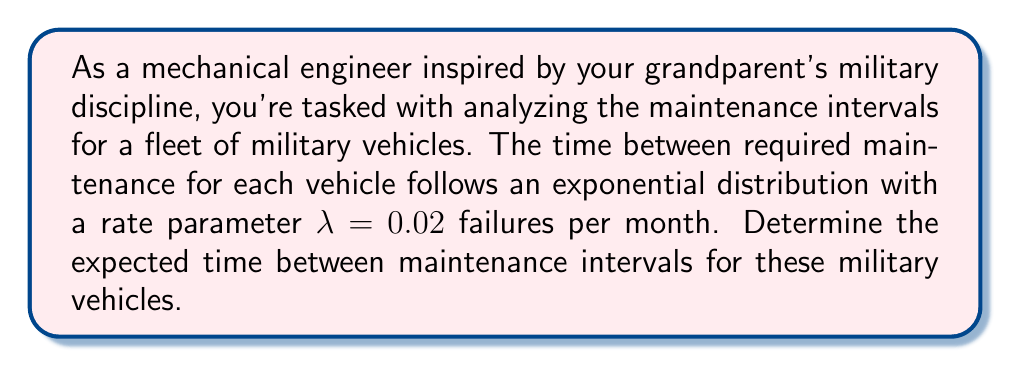Can you solve this math problem? Let's approach this step-by-step:

1) For an exponential distribution, the expected value (mean) is given by:

   $$ E[X] = \frac{1}{\lambda} $$

   where λ is the rate parameter.

2) We're given that λ = 0.02 failures per month.

3) Substituting this into our formula:

   $$ E[X] = \frac{1}{0.02} $$

4) Calculating this:

   $$ E[X] = 50 $$

5) Therefore, the expected time between maintenance intervals is 50 months.

6) To convert this to years for a more practical interpretation:

   $$ 50 \text{ months} \times \frac{1 \text{ year}}{12 \text{ months}} \approx 4.17 \text{ years} $$

This result aligns with the military's need for long-lasting, reliable equipment, reflecting the discipline and efficiency that your grandparent might have valued in their military career.
Answer: 50 months or approximately 4.17 years 